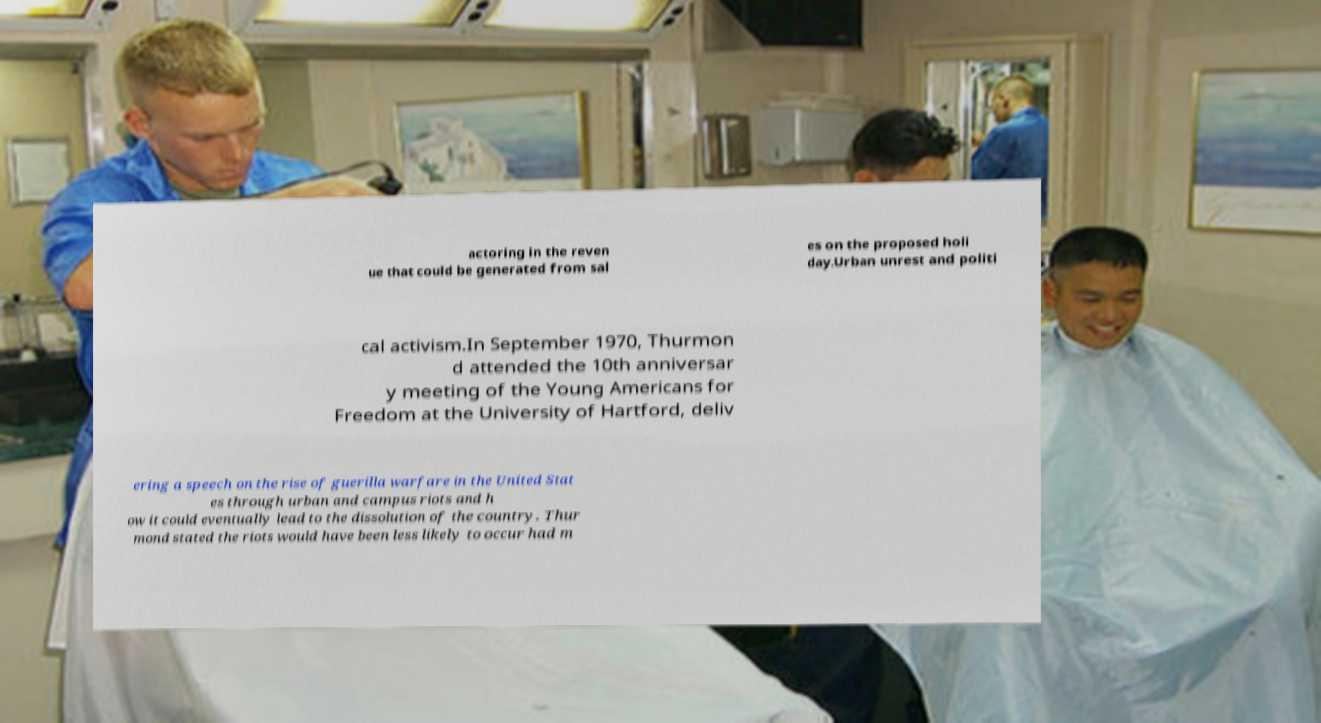I need the written content from this picture converted into text. Can you do that? actoring in the reven ue that could be generated from sal es on the proposed holi day.Urban unrest and politi cal activism.In September 1970, Thurmon d attended the 10th anniversar y meeting of the Young Americans for Freedom at the University of Hartford, deliv ering a speech on the rise of guerilla warfare in the United Stat es through urban and campus riots and h ow it could eventually lead to the dissolution of the country. Thur mond stated the riots would have been less likely to occur had m 